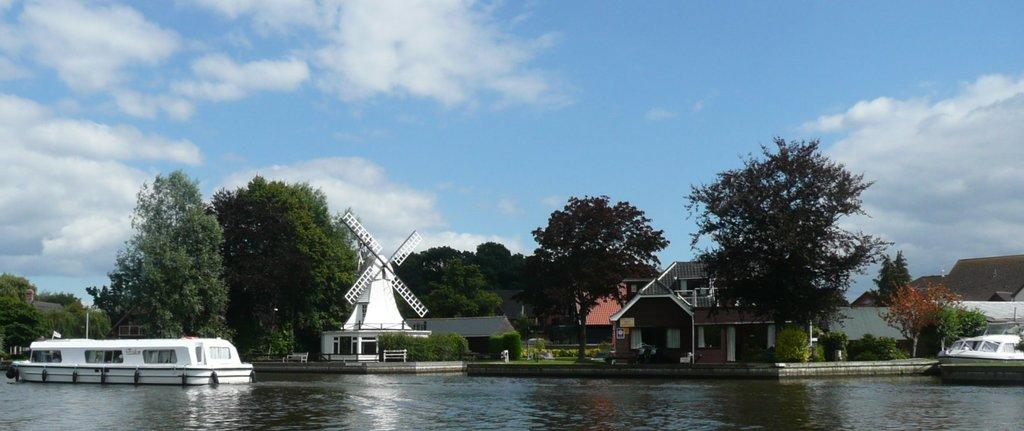What is in the water in the image? There are boats in the water. What structure can be seen in the image? There is a windmill in the image. What type of vegetation is visible in the background? There are trees in the background. What type of man-made structures are visible in the background? There are buildings in the background. How would you describe the sky in the image? The sky is blue and cloudy. Can you describe the owl sitting on the furniture in the image? There is no owl or furniture present in the image. What type of detail can be seen on the windmill in the image? The provided facts do not mention any specific details about the windmill, so we cannot answer this question. 